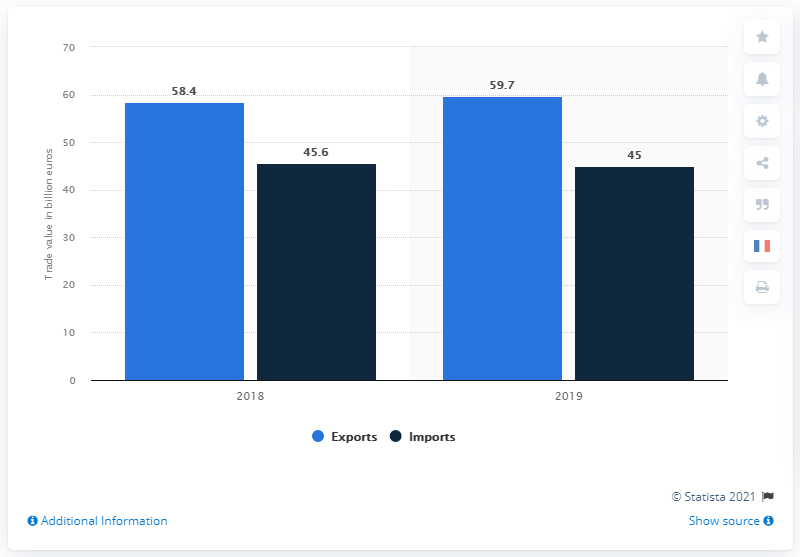What trend can be observed from the export values of 2018 to 2019? The graph shows a positive trend in export values of chemicals, cosmetics, and perfumes from France from 2018 to 2019, with an increase from 58.4 billion US dollars to 59.7 billion US dollars, highlighting growth in this sector. 